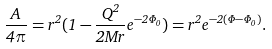Convert formula to latex. <formula><loc_0><loc_0><loc_500><loc_500>\frac { A } { 4 \pi } = r ^ { 2 } ( 1 - \frac { Q ^ { 2 } } { 2 M r } e ^ { - 2 \Phi _ { 0 } } ) = r ^ { 2 } e ^ { - 2 ( \Phi - \Phi _ { 0 } ) } .</formula> 